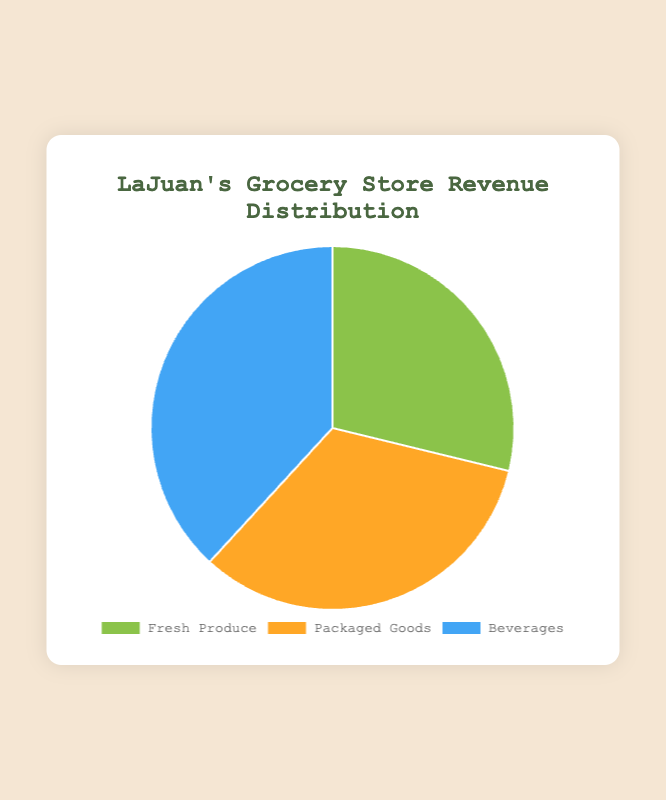What percentage of the revenue comes from Fresh Produce? The total revenue from Fresh Produce is $4450 (1500+1200+800+950). The overall revenue from all categories is $16550. Hence, the percentage of revenue from Fresh Produce is (4450/16550)*100 = 26.9%.
Answer: 26.9% Which category generates the most revenue? By examining the values, Fresh Produce totals to $4450, Packaged Goods to $5100, and Beverages to $7000. Beverages generate the most revenue.
Answer: Beverages How much more revenue does Beverages generate compared to Packaged Goods? Beverages generate $7000 and Packaged Goods generate $5100. The difference is 7000 - 5100 = 1900.
Answer: 1900 Is the revenue from Packaged Goods greater than the combined revenue from Apples and Tomatoes? Revenue from Packaged Goods is $5100. Revenue from Apples and Tomatoes combined is 1500 + 950 = 2450. $5100 > $2450, so yes.
Answer: Yes Which product category forms the smallest portion of the pie chart? Fresh Produce accounts for $4450, Packaged Goods for $5100, and Beverages for $7000. Fresh Produce forms the smallest portion.
Answer: Fresh Produce What is the combined revenue from the two smallest product categories? Fresh Produce generates $4450 and Packaged Goods generates $5100. The combined revenue is 4450 + 5100 = 9550.
Answer: 9550 How does the revenue of Coffee compare to the total revenue of Fresh Produce? Coffee has a revenue of $1600, and Fresh Produce has $4450. $1600 is less than $4450.
Answer: Less What would be the new percentage of revenue for Fresh Produce if Bananas' revenue doubled? Doubling Bananas' revenue adds an additional $1200 to Fresh Produce, making it $5650. The new total revenue is $16550 + 1200 = $17750. The percentage is (5650/17750)*100 ≈ 31.8%.
Answer: 31.8% What proportion of the total revenue is generated from Soda? Soda generates $2000. The overall revenue from all categories is $16550. The proportion is (2000/16550) ≈ 0.121, which is about 12.1%.
Answer: 12.1% Which two products within Fresh Produce generate more revenue combined than Cereal alone? Apples and Bananas together generate more than Cereal: (1500 + 1200 = 2700) > 1800.
Answer: Apples and Bananas 